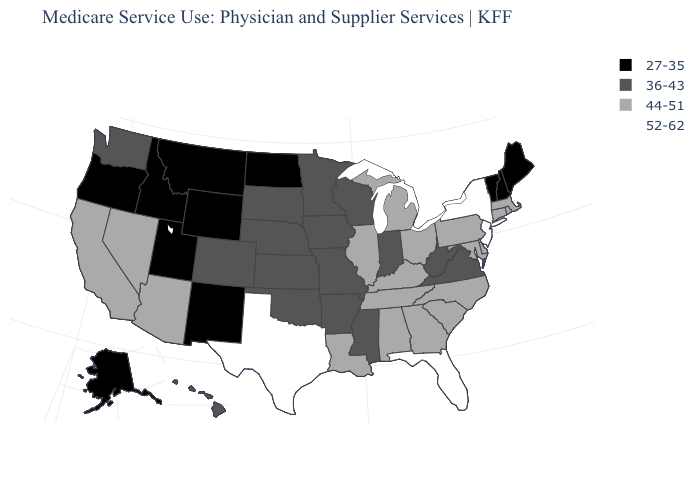Which states hav the highest value in the Northeast?
Keep it brief. New Jersey, New York. What is the value of Wisconsin?
Quick response, please. 36-43. What is the lowest value in states that border South Carolina?
Quick response, please. 44-51. What is the lowest value in states that border Pennsylvania?
Give a very brief answer. 36-43. What is the value of North Carolina?
Keep it brief. 44-51. Does the map have missing data?
Short answer required. No. Name the states that have a value in the range 44-51?
Give a very brief answer. Alabama, Arizona, California, Connecticut, Delaware, Georgia, Illinois, Kentucky, Louisiana, Maryland, Massachusetts, Michigan, Nevada, North Carolina, Ohio, Pennsylvania, Rhode Island, South Carolina, Tennessee. Does Michigan have the same value as Arkansas?
Short answer required. No. Does Massachusetts have the same value as Oregon?
Short answer required. No. What is the value of North Carolina?
Keep it brief. 44-51. Does Massachusetts have the lowest value in the Northeast?
Write a very short answer. No. What is the value of North Dakota?
Be succinct. 27-35. Name the states that have a value in the range 36-43?
Write a very short answer. Arkansas, Colorado, Hawaii, Indiana, Iowa, Kansas, Minnesota, Mississippi, Missouri, Nebraska, Oklahoma, South Dakota, Virginia, Washington, West Virginia, Wisconsin. Name the states that have a value in the range 44-51?
Keep it brief. Alabama, Arizona, California, Connecticut, Delaware, Georgia, Illinois, Kentucky, Louisiana, Maryland, Massachusetts, Michigan, Nevada, North Carolina, Ohio, Pennsylvania, Rhode Island, South Carolina, Tennessee. Does the map have missing data?
Short answer required. No. 